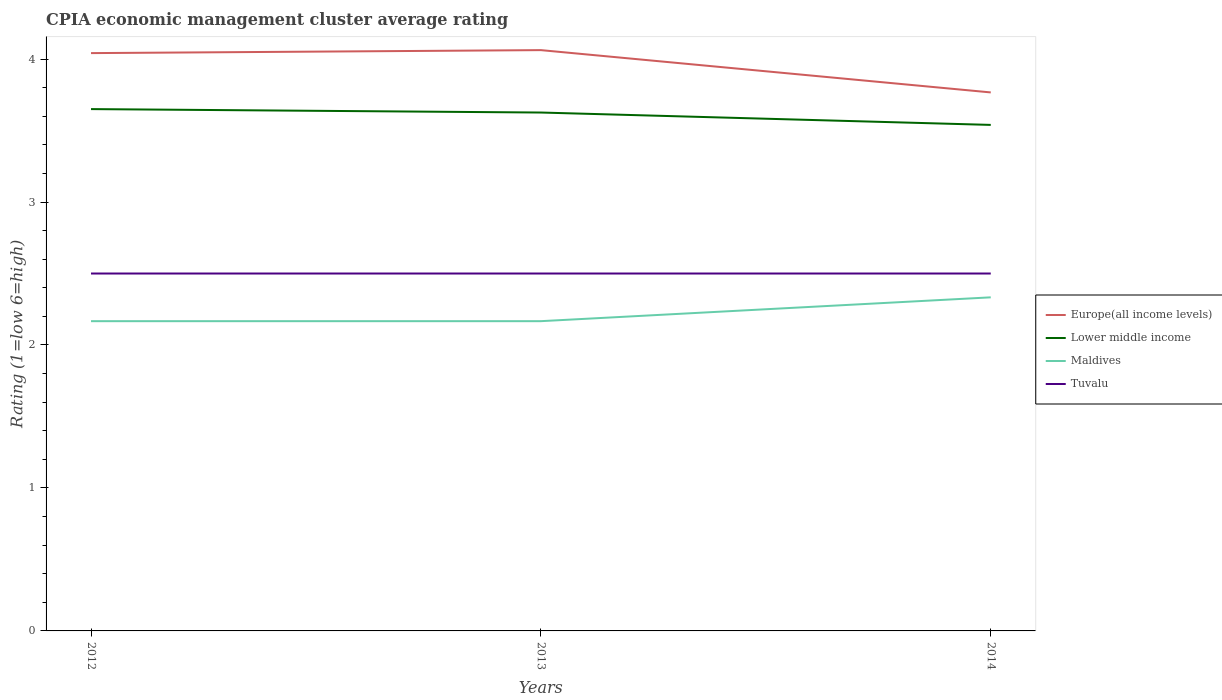Across all years, what is the maximum CPIA rating in Maldives?
Keep it short and to the point. 2.17. In which year was the CPIA rating in Europe(all income levels) maximum?
Offer a very short reply. 2014. What is the difference between the highest and the second highest CPIA rating in Maldives?
Offer a terse response. 0.17. Is the CPIA rating in Tuvalu strictly greater than the CPIA rating in Maldives over the years?
Keep it short and to the point. No. What is the difference between two consecutive major ticks on the Y-axis?
Your answer should be compact. 1. Does the graph contain grids?
Offer a very short reply. No. Where does the legend appear in the graph?
Your answer should be very brief. Center right. How many legend labels are there?
Offer a very short reply. 4. How are the legend labels stacked?
Your answer should be compact. Vertical. What is the title of the graph?
Keep it short and to the point. CPIA economic management cluster average rating. What is the Rating (1=low 6=high) of Europe(all income levels) in 2012?
Ensure brevity in your answer.  4.04. What is the Rating (1=low 6=high) in Lower middle income in 2012?
Provide a short and direct response. 3.65. What is the Rating (1=low 6=high) in Maldives in 2012?
Offer a terse response. 2.17. What is the Rating (1=low 6=high) in Europe(all income levels) in 2013?
Offer a very short reply. 4.06. What is the Rating (1=low 6=high) in Lower middle income in 2013?
Offer a very short reply. 3.63. What is the Rating (1=low 6=high) of Maldives in 2013?
Keep it short and to the point. 2.17. What is the Rating (1=low 6=high) in Europe(all income levels) in 2014?
Provide a short and direct response. 3.77. What is the Rating (1=low 6=high) in Lower middle income in 2014?
Your answer should be compact. 3.54. What is the Rating (1=low 6=high) of Maldives in 2014?
Your answer should be very brief. 2.33. Across all years, what is the maximum Rating (1=low 6=high) of Europe(all income levels)?
Provide a short and direct response. 4.06. Across all years, what is the maximum Rating (1=low 6=high) of Lower middle income?
Provide a short and direct response. 3.65. Across all years, what is the maximum Rating (1=low 6=high) in Maldives?
Give a very brief answer. 2.33. Across all years, what is the minimum Rating (1=low 6=high) in Europe(all income levels)?
Provide a short and direct response. 3.77. Across all years, what is the minimum Rating (1=low 6=high) in Lower middle income?
Your answer should be very brief. 3.54. Across all years, what is the minimum Rating (1=low 6=high) of Maldives?
Offer a terse response. 2.17. Across all years, what is the minimum Rating (1=low 6=high) of Tuvalu?
Your answer should be compact. 2.5. What is the total Rating (1=low 6=high) in Europe(all income levels) in the graph?
Your response must be concise. 11.87. What is the total Rating (1=low 6=high) of Lower middle income in the graph?
Make the answer very short. 10.82. What is the total Rating (1=low 6=high) of Maldives in the graph?
Give a very brief answer. 6.67. What is the total Rating (1=low 6=high) in Tuvalu in the graph?
Make the answer very short. 7.5. What is the difference between the Rating (1=low 6=high) in Europe(all income levels) in 2012 and that in 2013?
Make the answer very short. -0.02. What is the difference between the Rating (1=low 6=high) in Lower middle income in 2012 and that in 2013?
Your answer should be compact. 0.02. What is the difference between the Rating (1=low 6=high) of Maldives in 2012 and that in 2013?
Ensure brevity in your answer.  0. What is the difference between the Rating (1=low 6=high) of Europe(all income levels) in 2012 and that in 2014?
Your response must be concise. 0.28. What is the difference between the Rating (1=low 6=high) in Lower middle income in 2012 and that in 2014?
Keep it short and to the point. 0.11. What is the difference between the Rating (1=low 6=high) in Europe(all income levels) in 2013 and that in 2014?
Give a very brief answer. 0.3. What is the difference between the Rating (1=low 6=high) of Lower middle income in 2013 and that in 2014?
Your response must be concise. 0.09. What is the difference between the Rating (1=low 6=high) of Maldives in 2013 and that in 2014?
Your answer should be very brief. -0.17. What is the difference between the Rating (1=low 6=high) in Europe(all income levels) in 2012 and the Rating (1=low 6=high) in Lower middle income in 2013?
Give a very brief answer. 0.42. What is the difference between the Rating (1=low 6=high) in Europe(all income levels) in 2012 and the Rating (1=low 6=high) in Maldives in 2013?
Give a very brief answer. 1.88. What is the difference between the Rating (1=low 6=high) of Europe(all income levels) in 2012 and the Rating (1=low 6=high) of Tuvalu in 2013?
Give a very brief answer. 1.54. What is the difference between the Rating (1=low 6=high) of Lower middle income in 2012 and the Rating (1=low 6=high) of Maldives in 2013?
Offer a terse response. 1.48. What is the difference between the Rating (1=low 6=high) of Lower middle income in 2012 and the Rating (1=low 6=high) of Tuvalu in 2013?
Your answer should be compact. 1.15. What is the difference between the Rating (1=low 6=high) in Maldives in 2012 and the Rating (1=low 6=high) in Tuvalu in 2013?
Give a very brief answer. -0.33. What is the difference between the Rating (1=low 6=high) in Europe(all income levels) in 2012 and the Rating (1=low 6=high) in Lower middle income in 2014?
Make the answer very short. 0.5. What is the difference between the Rating (1=low 6=high) of Europe(all income levels) in 2012 and the Rating (1=low 6=high) of Maldives in 2014?
Your answer should be compact. 1.71. What is the difference between the Rating (1=low 6=high) in Europe(all income levels) in 2012 and the Rating (1=low 6=high) in Tuvalu in 2014?
Make the answer very short. 1.54. What is the difference between the Rating (1=low 6=high) in Lower middle income in 2012 and the Rating (1=low 6=high) in Maldives in 2014?
Your answer should be compact. 1.32. What is the difference between the Rating (1=low 6=high) of Lower middle income in 2012 and the Rating (1=low 6=high) of Tuvalu in 2014?
Offer a very short reply. 1.15. What is the difference between the Rating (1=low 6=high) of Europe(all income levels) in 2013 and the Rating (1=low 6=high) of Lower middle income in 2014?
Your answer should be compact. 0.52. What is the difference between the Rating (1=low 6=high) in Europe(all income levels) in 2013 and the Rating (1=low 6=high) in Maldives in 2014?
Give a very brief answer. 1.73. What is the difference between the Rating (1=low 6=high) in Europe(all income levels) in 2013 and the Rating (1=low 6=high) in Tuvalu in 2014?
Offer a very short reply. 1.56. What is the difference between the Rating (1=low 6=high) in Lower middle income in 2013 and the Rating (1=low 6=high) in Maldives in 2014?
Your answer should be very brief. 1.29. What is the difference between the Rating (1=low 6=high) in Lower middle income in 2013 and the Rating (1=low 6=high) in Tuvalu in 2014?
Make the answer very short. 1.13. What is the difference between the Rating (1=low 6=high) in Maldives in 2013 and the Rating (1=low 6=high) in Tuvalu in 2014?
Give a very brief answer. -0.33. What is the average Rating (1=low 6=high) of Europe(all income levels) per year?
Your response must be concise. 3.96. What is the average Rating (1=low 6=high) in Lower middle income per year?
Offer a very short reply. 3.61. What is the average Rating (1=low 6=high) of Maldives per year?
Offer a terse response. 2.22. What is the average Rating (1=low 6=high) of Tuvalu per year?
Your answer should be very brief. 2.5. In the year 2012, what is the difference between the Rating (1=low 6=high) of Europe(all income levels) and Rating (1=low 6=high) of Lower middle income?
Provide a short and direct response. 0.39. In the year 2012, what is the difference between the Rating (1=low 6=high) in Europe(all income levels) and Rating (1=low 6=high) in Maldives?
Your answer should be compact. 1.88. In the year 2012, what is the difference between the Rating (1=low 6=high) of Europe(all income levels) and Rating (1=low 6=high) of Tuvalu?
Provide a short and direct response. 1.54. In the year 2012, what is the difference between the Rating (1=low 6=high) of Lower middle income and Rating (1=low 6=high) of Maldives?
Your answer should be compact. 1.48. In the year 2012, what is the difference between the Rating (1=low 6=high) in Lower middle income and Rating (1=low 6=high) in Tuvalu?
Ensure brevity in your answer.  1.15. In the year 2013, what is the difference between the Rating (1=low 6=high) of Europe(all income levels) and Rating (1=low 6=high) of Lower middle income?
Provide a short and direct response. 0.44. In the year 2013, what is the difference between the Rating (1=low 6=high) of Europe(all income levels) and Rating (1=low 6=high) of Maldives?
Provide a succinct answer. 1.9. In the year 2013, what is the difference between the Rating (1=low 6=high) of Europe(all income levels) and Rating (1=low 6=high) of Tuvalu?
Keep it short and to the point. 1.56. In the year 2013, what is the difference between the Rating (1=low 6=high) in Lower middle income and Rating (1=low 6=high) in Maldives?
Offer a very short reply. 1.46. In the year 2013, what is the difference between the Rating (1=low 6=high) of Lower middle income and Rating (1=low 6=high) of Tuvalu?
Provide a succinct answer. 1.13. In the year 2014, what is the difference between the Rating (1=low 6=high) of Europe(all income levels) and Rating (1=low 6=high) of Lower middle income?
Keep it short and to the point. 0.23. In the year 2014, what is the difference between the Rating (1=low 6=high) in Europe(all income levels) and Rating (1=low 6=high) in Maldives?
Give a very brief answer. 1.43. In the year 2014, what is the difference between the Rating (1=low 6=high) in Europe(all income levels) and Rating (1=low 6=high) in Tuvalu?
Your answer should be compact. 1.27. In the year 2014, what is the difference between the Rating (1=low 6=high) of Lower middle income and Rating (1=low 6=high) of Maldives?
Your response must be concise. 1.21. In the year 2014, what is the difference between the Rating (1=low 6=high) in Lower middle income and Rating (1=low 6=high) in Tuvalu?
Your answer should be compact. 1.04. What is the ratio of the Rating (1=low 6=high) in Europe(all income levels) in 2012 to that in 2013?
Make the answer very short. 0.99. What is the ratio of the Rating (1=low 6=high) of Lower middle income in 2012 to that in 2013?
Your answer should be very brief. 1.01. What is the ratio of the Rating (1=low 6=high) in Europe(all income levels) in 2012 to that in 2014?
Provide a short and direct response. 1.07. What is the ratio of the Rating (1=low 6=high) of Lower middle income in 2012 to that in 2014?
Provide a succinct answer. 1.03. What is the ratio of the Rating (1=low 6=high) in Maldives in 2012 to that in 2014?
Your answer should be very brief. 0.93. What is the ratio of the Rating (1=low 6=high) of Europe(all income levels) in 2013 to that in 2014?
Make the answer very short. 1.08. What is the ratio of the Rating (1=low 6=high) of Lower middle income in 2013 to that in 2014?
Offer a terse response. 1.02. What is the ratio of the Rating (1=low 6=high) of Maldives in 2013 to that in 2014?
Your response must be concise. 0.93. What is the difference between the highest and the second highest Rating (1=low 6=high) of Europe(all income levels)?
Your answer should be very brief. 0.02. What is the difference between the highest and the second highest Rating (1=low 6=high) of Lower middle income?
Give a very brief answer. 0.02. What is the difference between the highest and the second highest Rating (1=low 6=high) of Maldives?
Give a very brief answer. 0.17. What is the difference between the highest and the lowest Rating (1=low 6=high) of Europe(all income levels)?
Ensure brevity in your answer.  0.3. What is the difference between the highest and the lowest Rating (1=low 6=high) in Lower middle income?
Provide a short and direct response. 0.11. What is the difference between the highest and the lowest Rating (1=low 6=high) in Tuvalu?
Give a very brief answer. 0. 